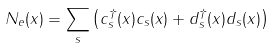Convert formula to latex. <formula><loc_0><loc_0><loc_500><loc_500>N _ { e } ( x ) = \sum _ { s } \left ( c ^ { \dagger } _ { s } ( x ) c _ { s } ( x ) + d ^ { \dagger } _ { s } ( x ) d _ { s } ( x ) \right )</formula> 